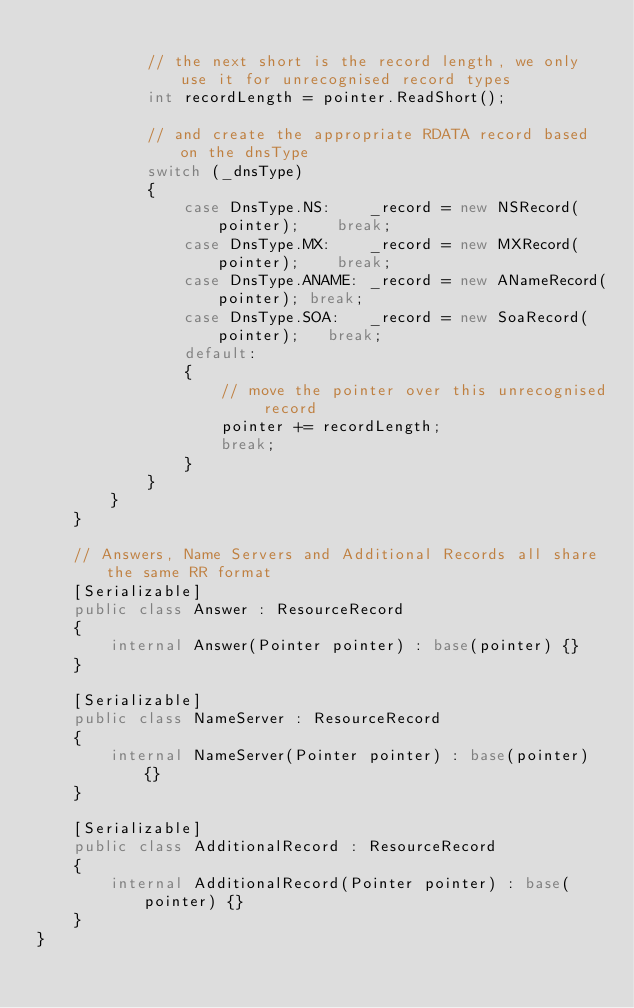Convert code to text. <code><loc_0><loc_0><loc_500><loc_500><_C#_>
			// the next short is the record length, we only use it for unrecognised record types
			int recordLength = pointer.ReadShort();

			// and create the appropriate RDATA record based on the dnsType
			switch (_dnsType)
			{
				case DnsType.NS:	_record = new NSRecord(pointer);	break;
				case DnsType.MX:	_record = new MXRecord(pointer);	break;
				case DnsType.ANAME:	_record = new ANameRecord(pointer);	break;
				case DnsType.SOA:	_record = new SoaRecord(pointer);	break;
				default:
				{
					// move the pointer over this unrecognised record
					pointer += recordLength;
					break;
				}
			}
		}
	}

	// Answers, Name Servers and Additional Records all share the same RR format
	[Serializable]
	public class Answer : ResourceRecord
	{
		internal Answer(Pointer pointer) : base(pointer) {}
	}

	[Serializable]
	public class NameServer : ResourceRecord
	{
		internal NameServer(Pointer pointer) : base(pointer) {}
	}

	[Serializable]
	public class AdditionalRecord : ResourceRecord
	{
		internal AdditionalRecord(Pointer pointer) : base(pointer) {}
	}
}</code> 